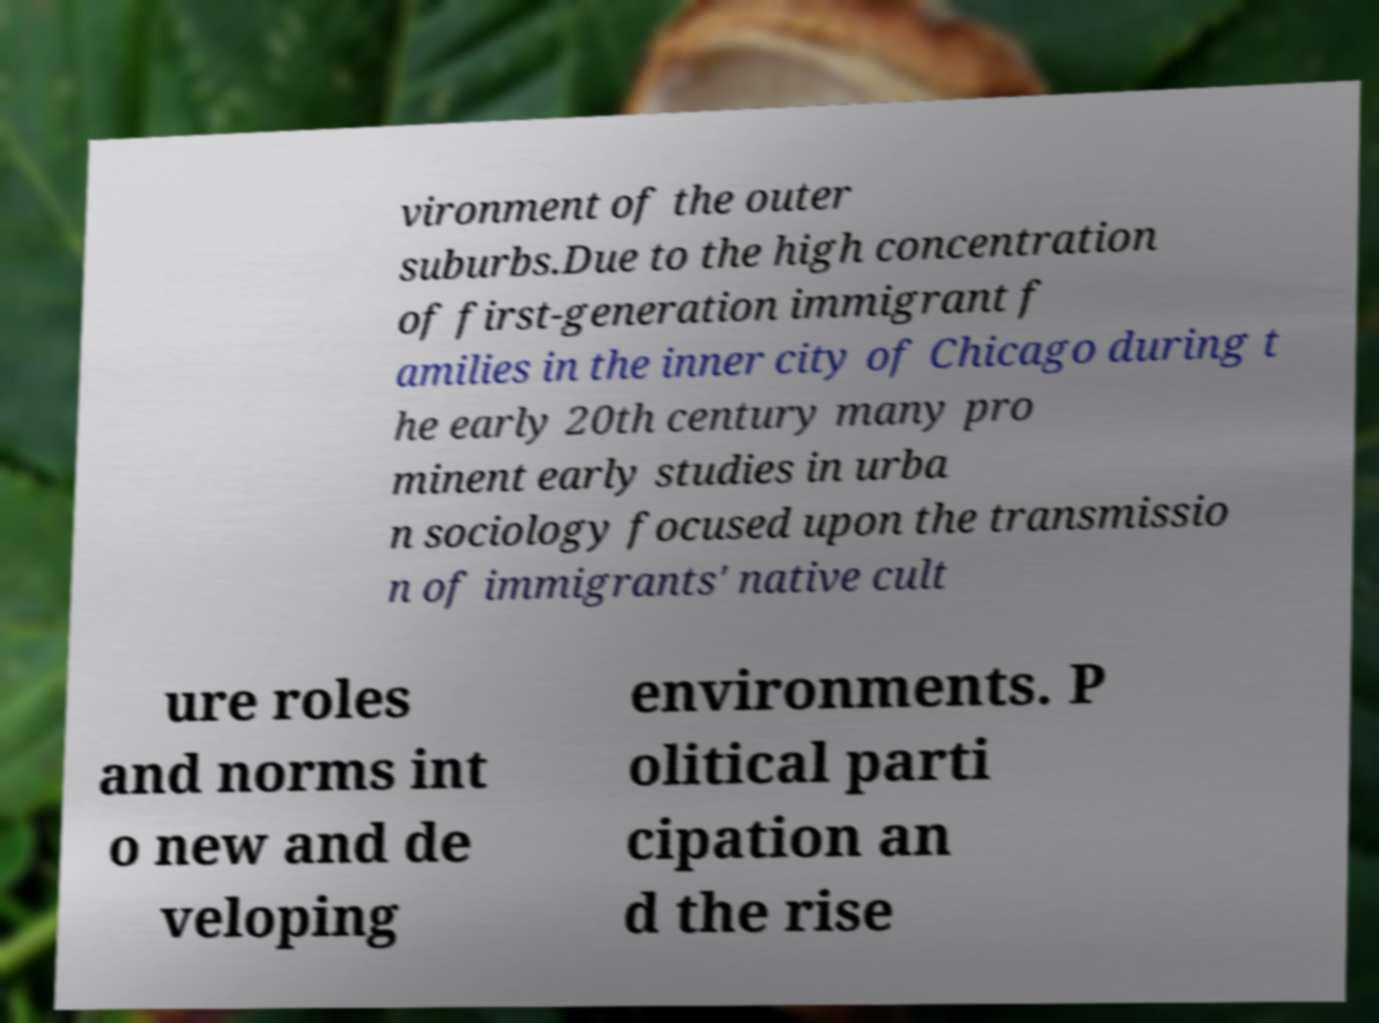What messages or text are displayed in this image? I need them in a readable, typed format. vironment of the outer suburbs.Due to the high concentration of first-generation immigrant f amilies in the inner city of Chicago during t he early 20th century many pro minent early studies in urba n sociology focused upon the transmissio n of immigrants' native cult ure roles and norms int o new and de veloping environments. P olitical parti cipation an d the rise 